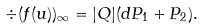<formula> <loc_0><loc_0><loc_500><loc_500>\div ( f ( u ) ) _ { \infty } = | Q | ( d P _ { 1 } + P _ { 2 } ) .</formula> 